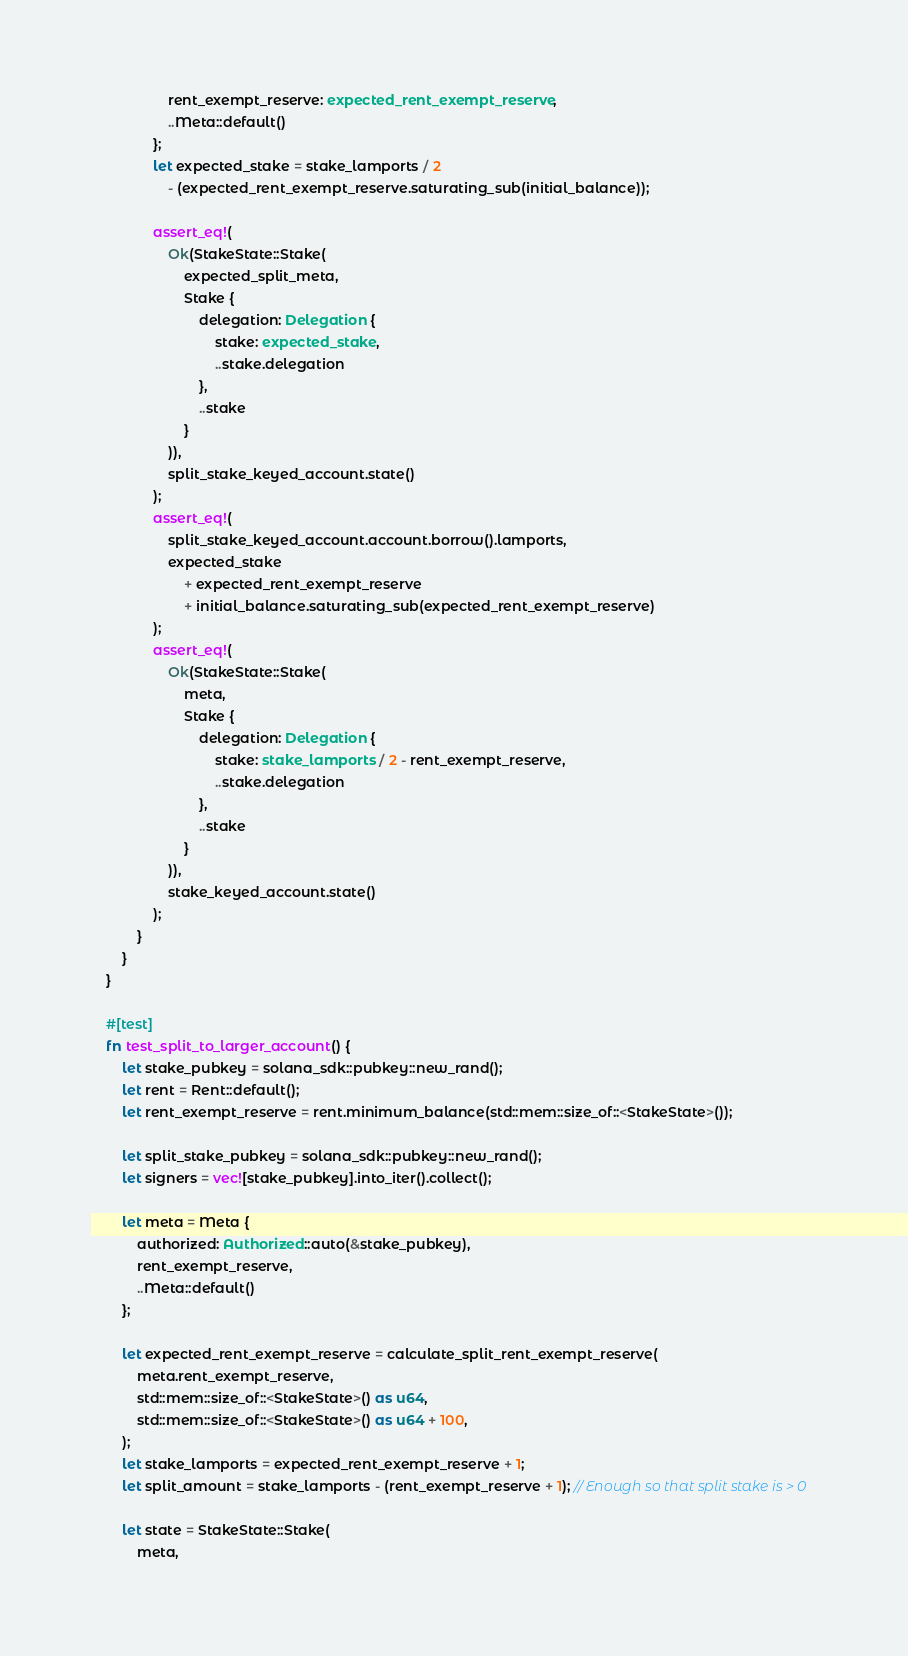<code> <loc_0><loc_0><loc_500><loc_500><_Rust_>                    rent_exempt_reserve: expected_rent_exempt_reserve,
                    ..Meta::default()
                };
                let expected_stake = stake_lamports / 2
                    - (expected_rent_exempt_reserve.saturating_sub(initial_balance));

                assert_eq!(
                    Ok(StakeState::Stake(
                        expected_split_meta,
                        Stake {
                            delegation: Delegation {
                                stake: expected_stake,
                                ..stake.delegation
                            },
                            ..stake
                        }
                    )),
                    split_stake_keyed_account.state()
                );
                assert_eq!(
                    split_stake_keyed_account.account.borrow().lamports,
                    expected_stake
                        + expected_rent_exempt_reserve
                        + initial_balance.saturating_sub(expected_rent_exempt_reserve)
                );
                assert_eq!(
                    Ok(StakeState::Stake(
                        meta,
                        Stake {
                            delegation: Delegation {
                                stake: stake_lamports / 2 - rent_exempt_reserve,
                                ..stake.delegation
                            },
                            ..stake
                        }
                    )),
                    stake_keyed_account.state()
                );
            }
        }
    }

    #[test]
    fn test_split_to_larger_account() {
        let stake_pubkey = solana_sdk::pubkey::new_rand();
        let rent = Rent::default();
        let rent_exempt_reserve = rent.minimum_balance(std::mem::size_of::<StakeState>());

        let split_stake_pubkey = solana_sdk::pubkey::new_rand();
        let signers = vec![stake_pubkey].into_iter().collect();

        let meta = Meta {
            authorized: Authorized::auto(&stake_pubkey),
            rent_exempt_reserve,
            ..Meta::default()
        };

        let expected_rent_exempt_reserve = calculate_split_rent_exempt_reserve(
            meta.rent_exempt_reserve,
            std::mem::size_of::<StakeState>() as u64,
            std::mem::size_of::<StakeState>() as u64 + 100,
        );
        let stake_lamports = expected_rent_exempt_reserve + 1;
        let split_amount = stake_lamports - (rent_exempt_reserve + 1); // Enough so that split stake is > 0

        let state = StakeState::Stake(
            meta,</code> 